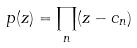<formula> <loc_0><loc_0><loc_500><loc_500>p ( z ) = \prod _ { n } ( z - c _ { n } )</formula> 